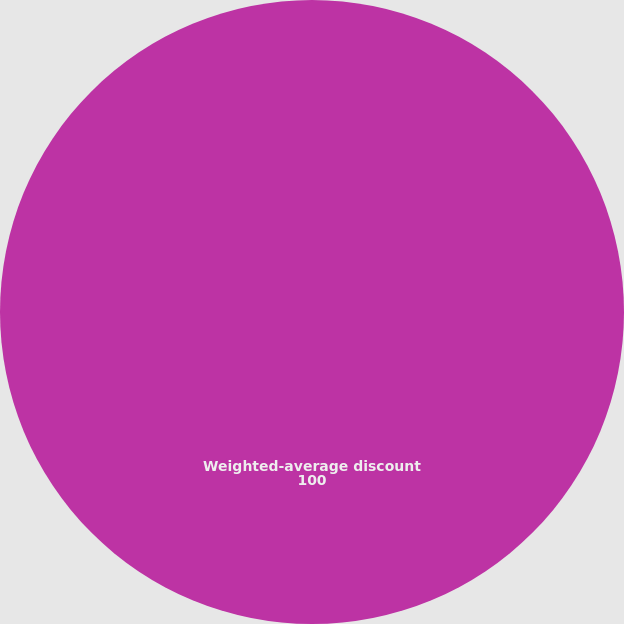Convert chart. <chart><loc_0><loc_0><loc_500><loc_500><pie_chart><fcel>Weighted-average discount<nl><fcel>100.0%<nl></chart> 